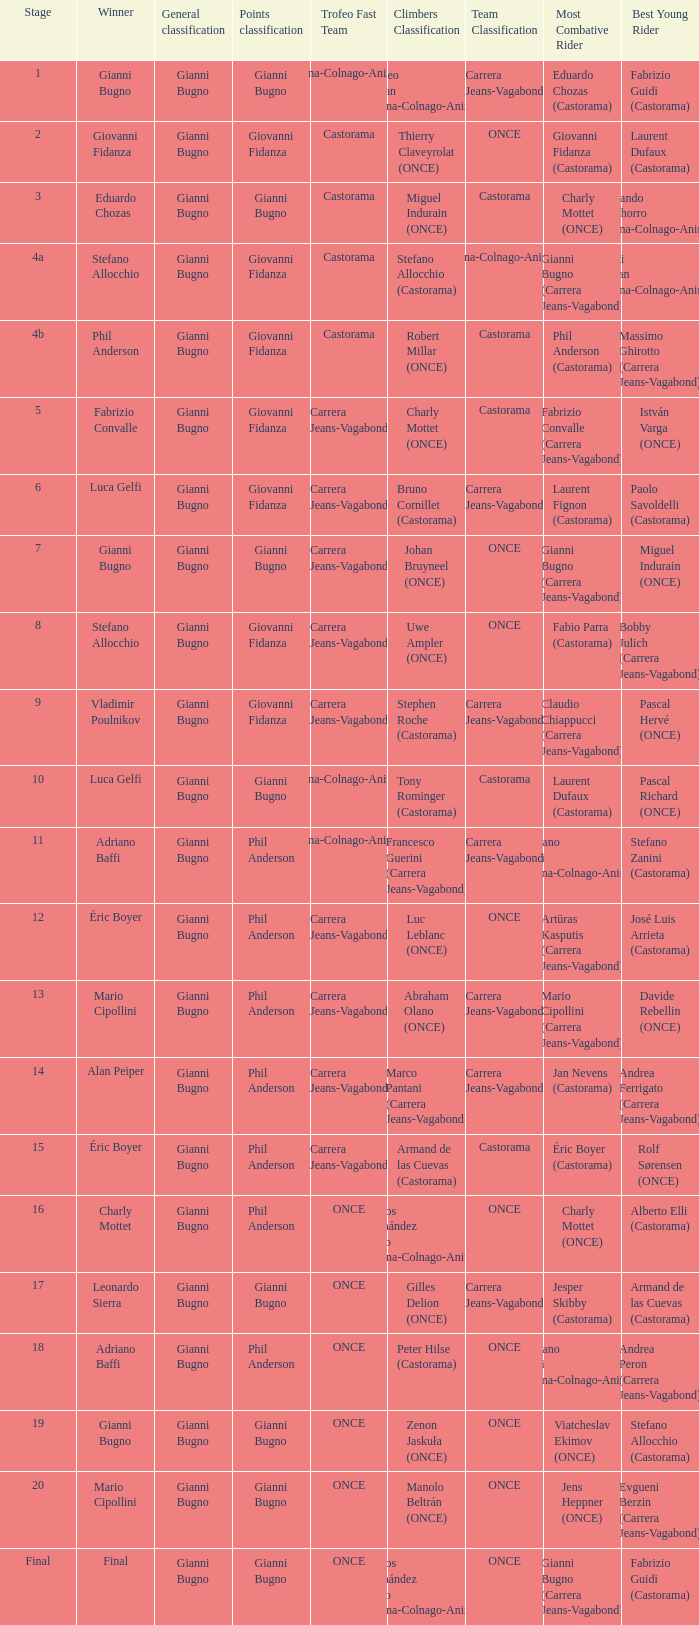Who was the trofeo fast team in stage 10? Diana-Colnago-Animex. 